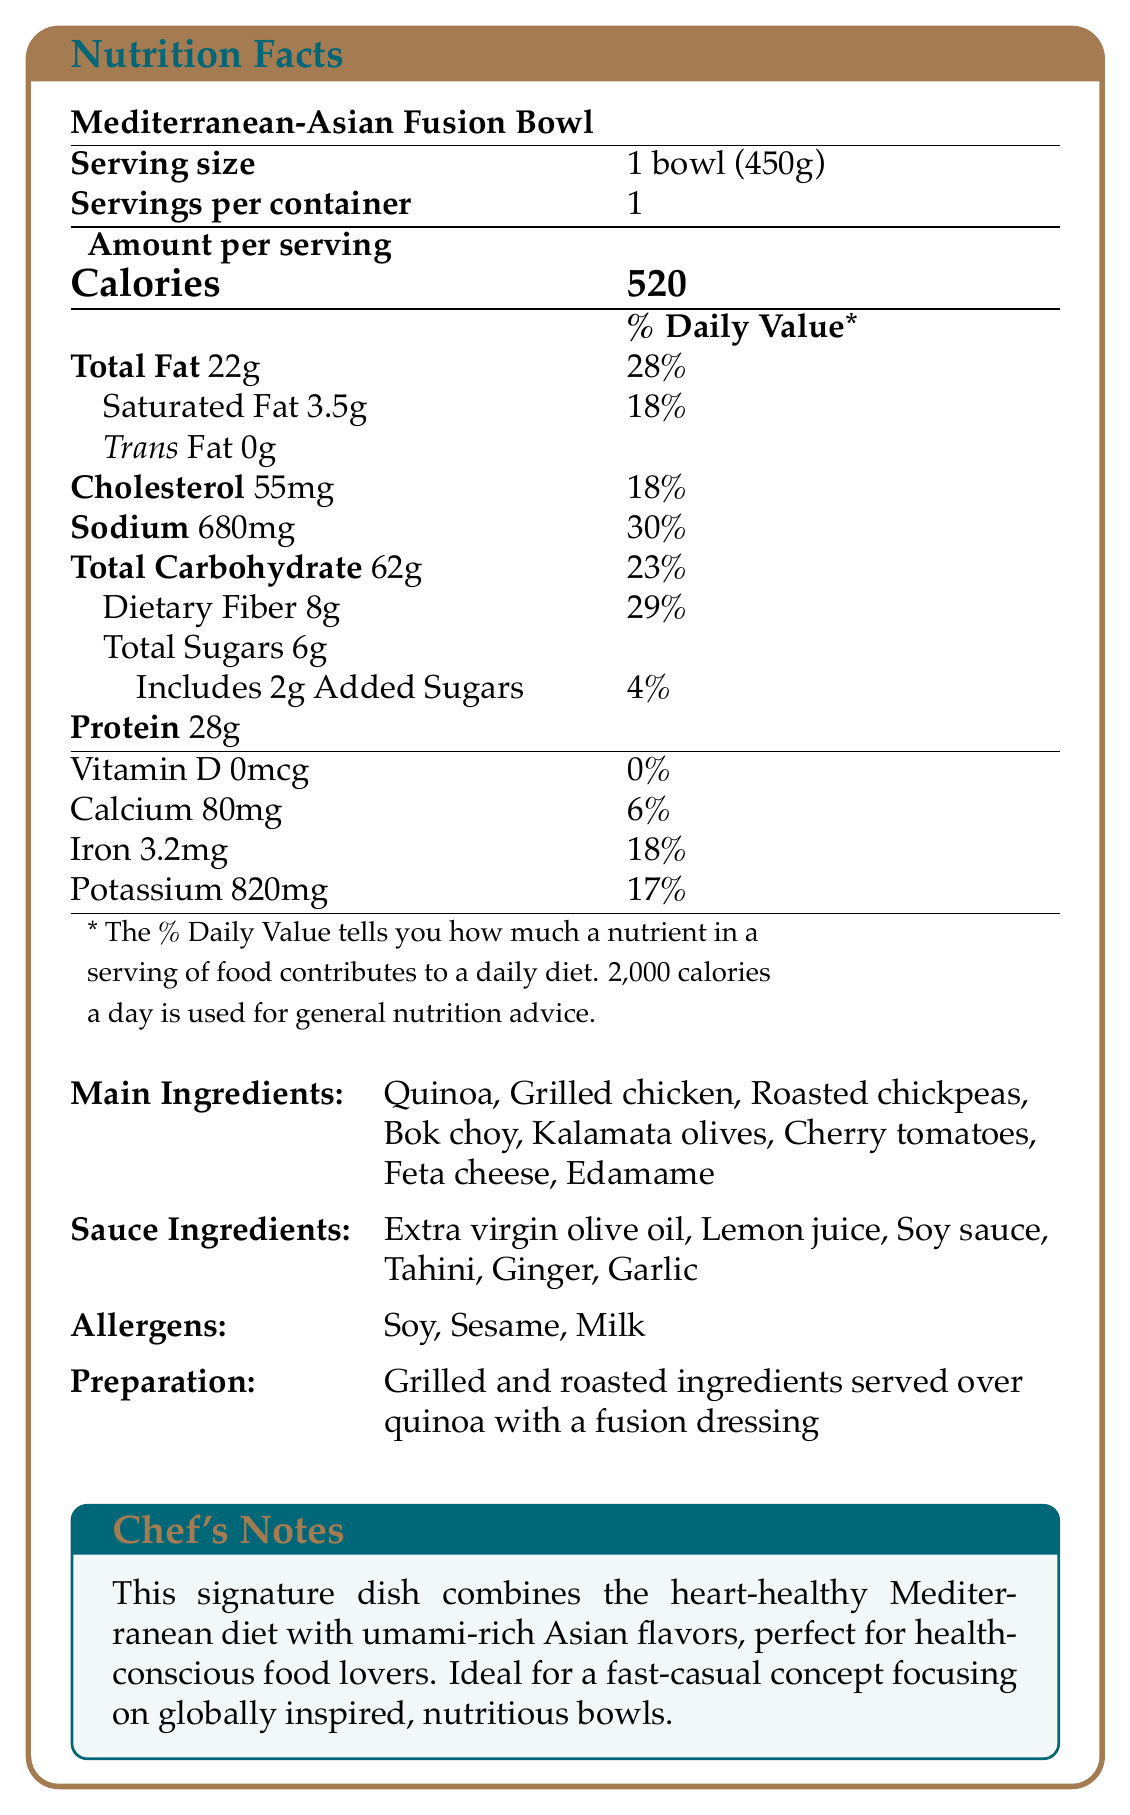what is the serving size for the Mediterranean-Asian Fusion Bowl? The serving size is clearly mentioned in the document as "1 bowl (450g)".
Answer: 1 bowl (450g) how many calories are there per serving of the dish? The document states that there are 520 calories per serving.
Answer: 520 which allergens are present in the dish? The document lists the allergens present in the dish as "Soy, Sesame, Milk".
Answer: Soy, Sesame, Milk what is the daily value percentage of sodium in the dish? The document states that the sodium content is 680mg, which corresponds to 30% of the daily value.
Answer: 30% list the main ingredients used in the Mediterranean-Asian Fusion Bowl. The main ingredients are clearly listed in the document.
Answer: Quinoa, Grilled chicken, Roasted chickpeas, Bok choy, Kalamata olives, Cherry tomatoes, Feta cheese, Edamame how much protein does the dish contain? The document specifies that the dish contains 28 grams of protein.
Answer: 28g what type of fats are included, and what are their amounts? The document provides the amounts for Total Fat (22g), Saturated Fat (3.5g), and Trans Fat (0g).
Answer: Total Fat: 22g, Saturated Fat: 3.5g, Trans Fat: 0g is there any trans fat in the Mediterranean-Asian Fusion Bowl? The document states that there is 0g of trans fat in the dish.
Answer: No how is the dish prepared? The document mentions that the preparation method involves grilling and roasting ingredients, which are then served over quinoa with a fusion dressing.
Answer: Grilled and roasted ingredients served over quinoa with a fusion dressing what are the possible restaurant chain potentials for this dish? The document notes that the dish is ideal for a fast-casual restaurant chain focusing on globally inspired, nutritious bowls.
Answer: Ideal for a fast-casual concept focusing on globally inspired, nutritious bowls how much added sugar is in the dish? The document lists 2 grams of added sugars in the dish.
Answer: 2g how would you describe the main idea of the document? The document provides comprehensive information about the Mediterranean-Asian Fusion Bowl, including its nutritional content, ingredients, allergens, and preparation method, along with its potential for a fast-casual restaurant concept.
Answer: The document details the nutritional facts, ingredients, allergens, preparation method, and restaurant chain potential for a signature fusion dish called the Mediterranean-Asian Fusion Bowl. which nutrient in the dish contributes the highest percentage to its daily value? A. Sodium B. Total Carbohydrate C. Dietary Fiber D. Total Fat The nutrient values are Sodium (30%), Total Carbohydrate (23%), Dietary Fiber (29%), Total Fat (28%). Sodium has the highest daily value percentage at 30%.
Answer: A. Sodium which of the following main ingredients is a type of cheese? A. Edamame B. Bok choy C. Feta cheese D. Quinoa Among the listed ingredients, Feta cheese is the only type of cheese.
Answer: C. Feta cheese how many servings are there per container of the Mediterranean-Asian Fusion Bowl? The document clearly states that there is 1 serving per container.
Answer: 1 does the dish contain any vitamin D? The document shows that the amount of Vitamin D is 0mcg and its daily value is 0%, indicating that there is no vitamin D in the dish.
Answer: No how much calcium does the Mediterranean-Asian Fusion Bowl provide? The document mentions that the dish contains 80mg of calcium.
Answer: 80mg what type of oil is used in the sauce for this dish? The document states that one of the sauce ingredients is extra virgin olive oil.
Answer: Extra virgin olive oil how many ingredients are in the sauce for this dish? The document lists 6 sauce ingredients: Extra virgin olive oil, Lemon juice, Soy sauce, Tahini, Ginger, and Garlic.
Answer: 6 can you find the specific cooking times for each ingredient? The document does not provide specific cooking times for each ingredient.
Answer: Not enough information 